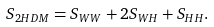<formula> <loc_0><loc_0><loc_500><loc_500>S _ { 2 H D M } = S _ { W W } + 2 S _ { W H } + S _ { H H } .</formula> 